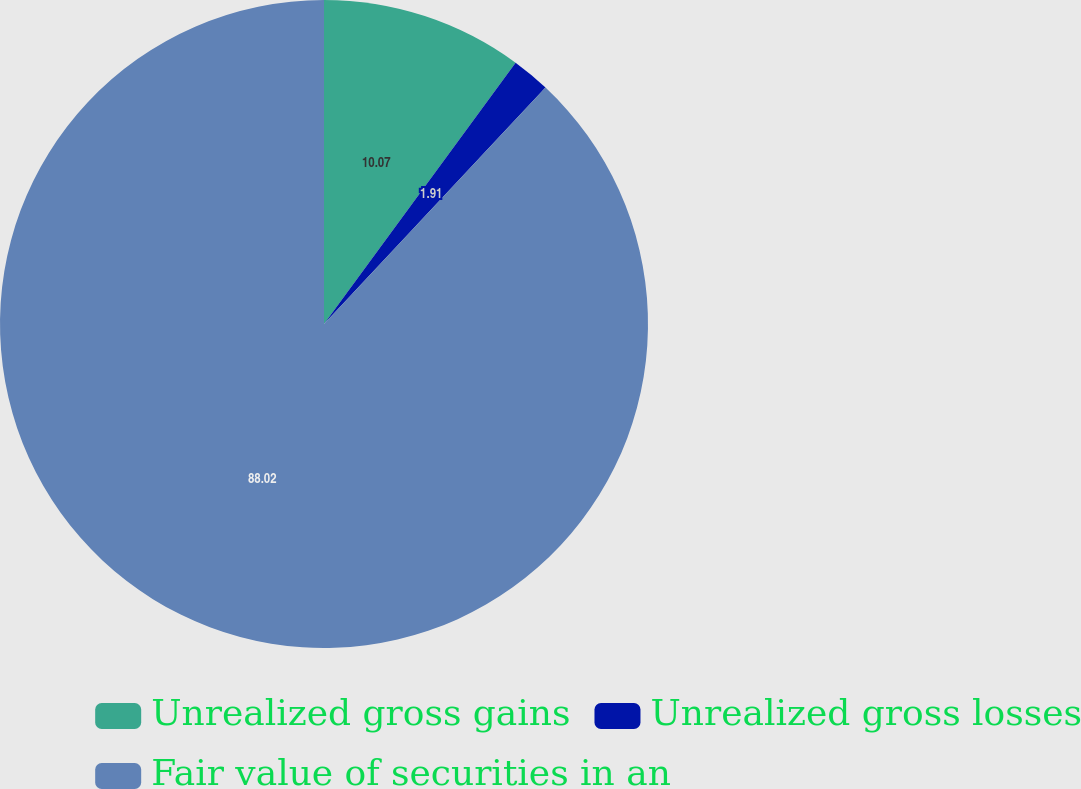Convert chart. <chart><loc_0><loc_0><loc_500><loc_500><pie_chart><fcel>Unrealized gross gains<fcel>Unrealized gross losses<fcel>Fair value of securities in an<nl><fcel>10.07%<fcel>1.91%<fcel>88.02%<nl></chart> 